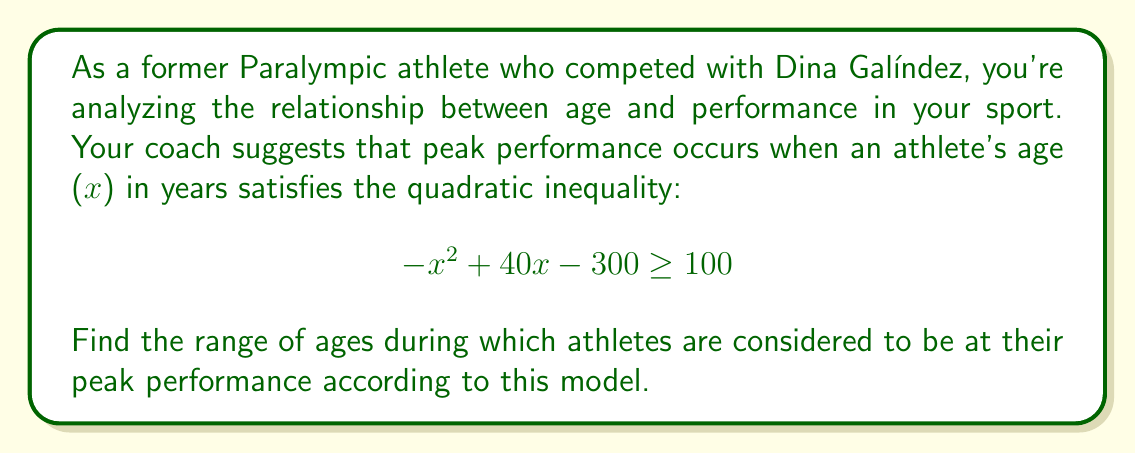Show me your answer to this math problem. 1) First, we need to solve the quadratic inequality:
   $$ -x^2 + 40x - 300 \geq 100 $$

2) Rearrange the inequality to standard form:
   $$ -x^2 + 40x - 400 \geq 0 $$

3) This is a downward-facing parabola (coefficient of $x^2$ is negative). We need to find the roots of the equation:
   $$ -x^2 + 40x - 400 = 0 $$

4) Use the quadratic formula: $x = \frac{-b \pm \sqrt{b^2 - 4ac}}{2a}$
   Where $a=-1$, $b=40$, and $c=-400$

5) Substituting:
   $$ x = \frac{-40 \pm \sqrt{40^2 - 4(-1)(-400)}}{2(-1)} $$
   $$ = \frac{-40 \pm \sqrt{1600 - 1600}}{-2} $$
   $$ = \frac{-40 \pm 0}{-2} $$
   $$ = 20 $$

6) Both roots are the same, 20. This means the parabola touches the x-axis at one point.

7) Since it's a downward-facing parabola and we're looking for when it's greater than or equal to zero, the solution is the single point x = 20.

8) Therefore, according to this model, athletes are at their peak performance at exactly 20 years old.
Answer: 20 years old 